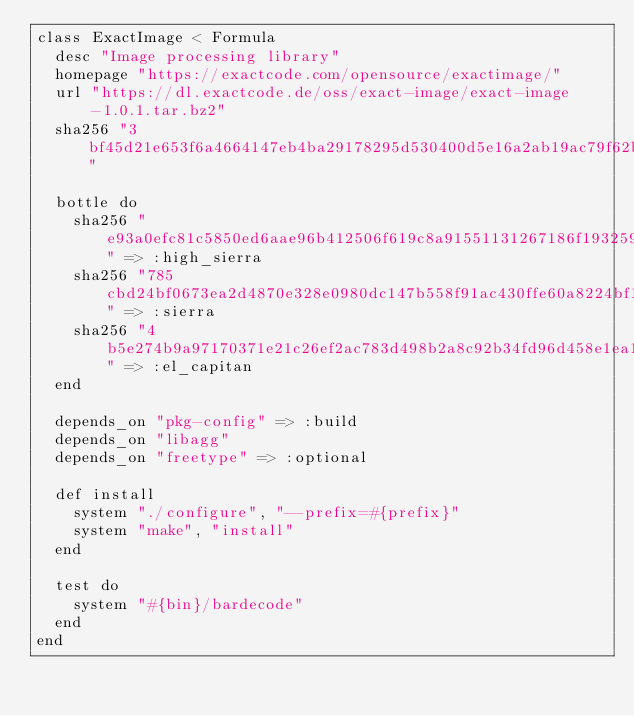<code> <loc_0><loc_0><loc_500><loc_500><_Ruby_>class ExactImage < Formula
  desc "Image processing library"
  homepage "https://exactcode.com/opensource/exactimage/"
  url "https://dl.exactcode.de/oss/exact-image/exact-image-1.0.1.tar.bz2"
  sha256 "3bf45d21e653f6a4664147eb4ba29178295d530400d5e16a2ab19ac79f62b76c"

  bottle do
    sha256 "e93a0efc81c5850ed6aae96b412506f619c8a91551131267186f193259b1a730" => :high_sierra
    sha256 "785cbd24bf0673ea2d4870e328e0980dc147b558f91ac430ffe60a8224bf1c5d" => :sierra
    sha256 "4b5e274b9a97170371e21c26ef2ac783d498b2a8c92b34fd96d458e1ea10796b" => :el_capitan
  end

  depends_on "pkg-config" => :build
  depends_on "libagg"
  depends_on "freetype" => :optional

  def install
    system "./configure", "--prefix=#{prefix}"
    system "make", "install"
  end

  test do
    system "#{bin}/bardecode"
  end
end
</code> 